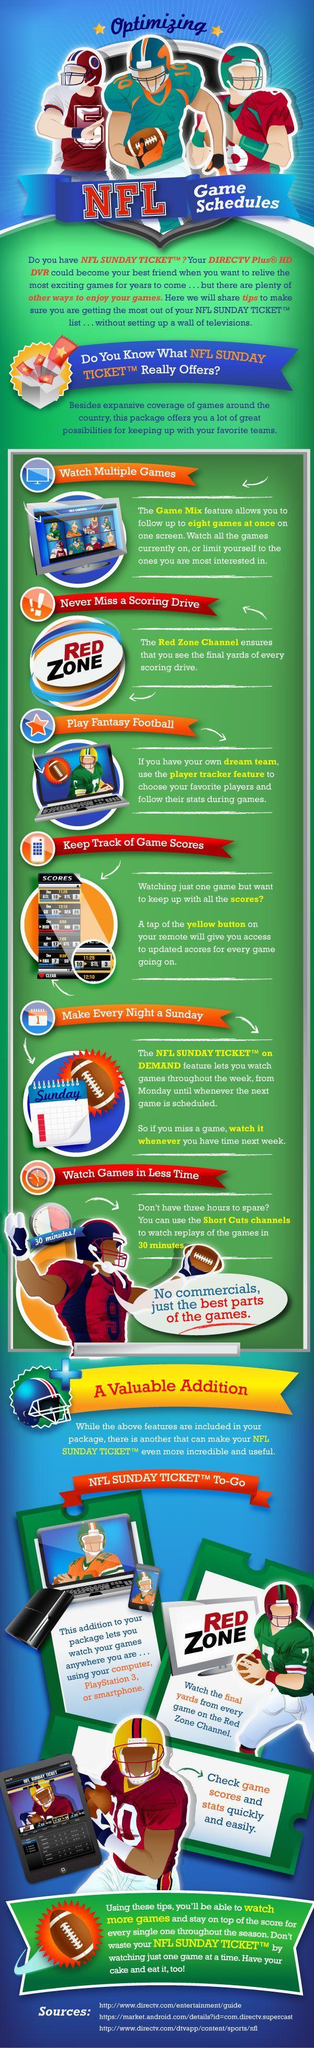Which feature allows users to watch games on smartphone, computer or PlayStation 3?
Answer the question with a short phrase. NFL Sunday Ticket To-Go 